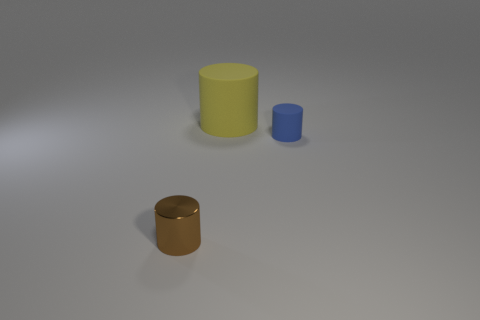What number of cylinders are in front of the blue matte cylinder?
Your answer should be very brief. 1. Is the shape of the thing behind the blue matte cylinder the same as the small blue rubber object that is right of the yellow thing?
Give a very brief answer. Yes. What number of other things are there of the same color as the tiny metal thing?
Your response must be concise. 0. What material is the small thing that is right of the small object left of the small object behind the brown metallic object made of?
Your answer should be very brief. Rubber. What material is the tiny object that is on the left side of the small cylinder behind the small brown cylinder?
Offer a very short reply. Metal. Are there fewer yellow rubber cylinders that are in front of the shiny thing than tiny metallic blocks?
Your answer should be very brief. No. The brown thing that is in front of the big object has what shape?
Your answer should be compact. Cylinder. There is a yellow cylinder; does it have the same size as the rubber cylinder that is in front of the large thing?
Make the answer very short. No. Are there any objects made of the same material as the blue cylinder?
Make the answer very short. Yes. What number of cubes are either tiny rubber things or brown matte objects?
Provide a succinct answer. 0. 